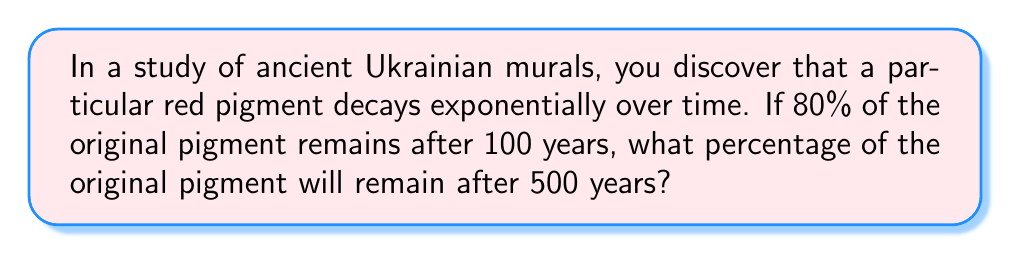Show me your answer to this math problem. Let's approach this step-by-step:

1) First, we need to find the decay rate. Let's call the decay rate $r$. We can use the exponential decay formula:

   $A = A_0 \cdot e^{-rt}$

   Where $A$ is the amount remaining, $A_0$ is the initial amount, $r$ is the decay rate, and $t$ is time.

2) We know that after 100 years, 80% remains. So:

   $0.8 = 1 \cdot e^{-r \cdot 100}$

3) Taking the natural log of both sides:

   $\ln(0.8) = -100r$

4) Solving for $r$:

   $r = -\frac{\ln(0.8)}{100} \approx 0.002231$

5) Now that we have $r$, we can use it to find the amount remaining after 500 years:

   $A = 1 \cdot e^{-0.002231 \cdot 500}$

6) Calculating this:

   $A \approx 0.3277$

7) Converting to a percentage:

   $0.3277 \cdot 100\% \approx 32.77\%$
Answer: $32.77\%$ 